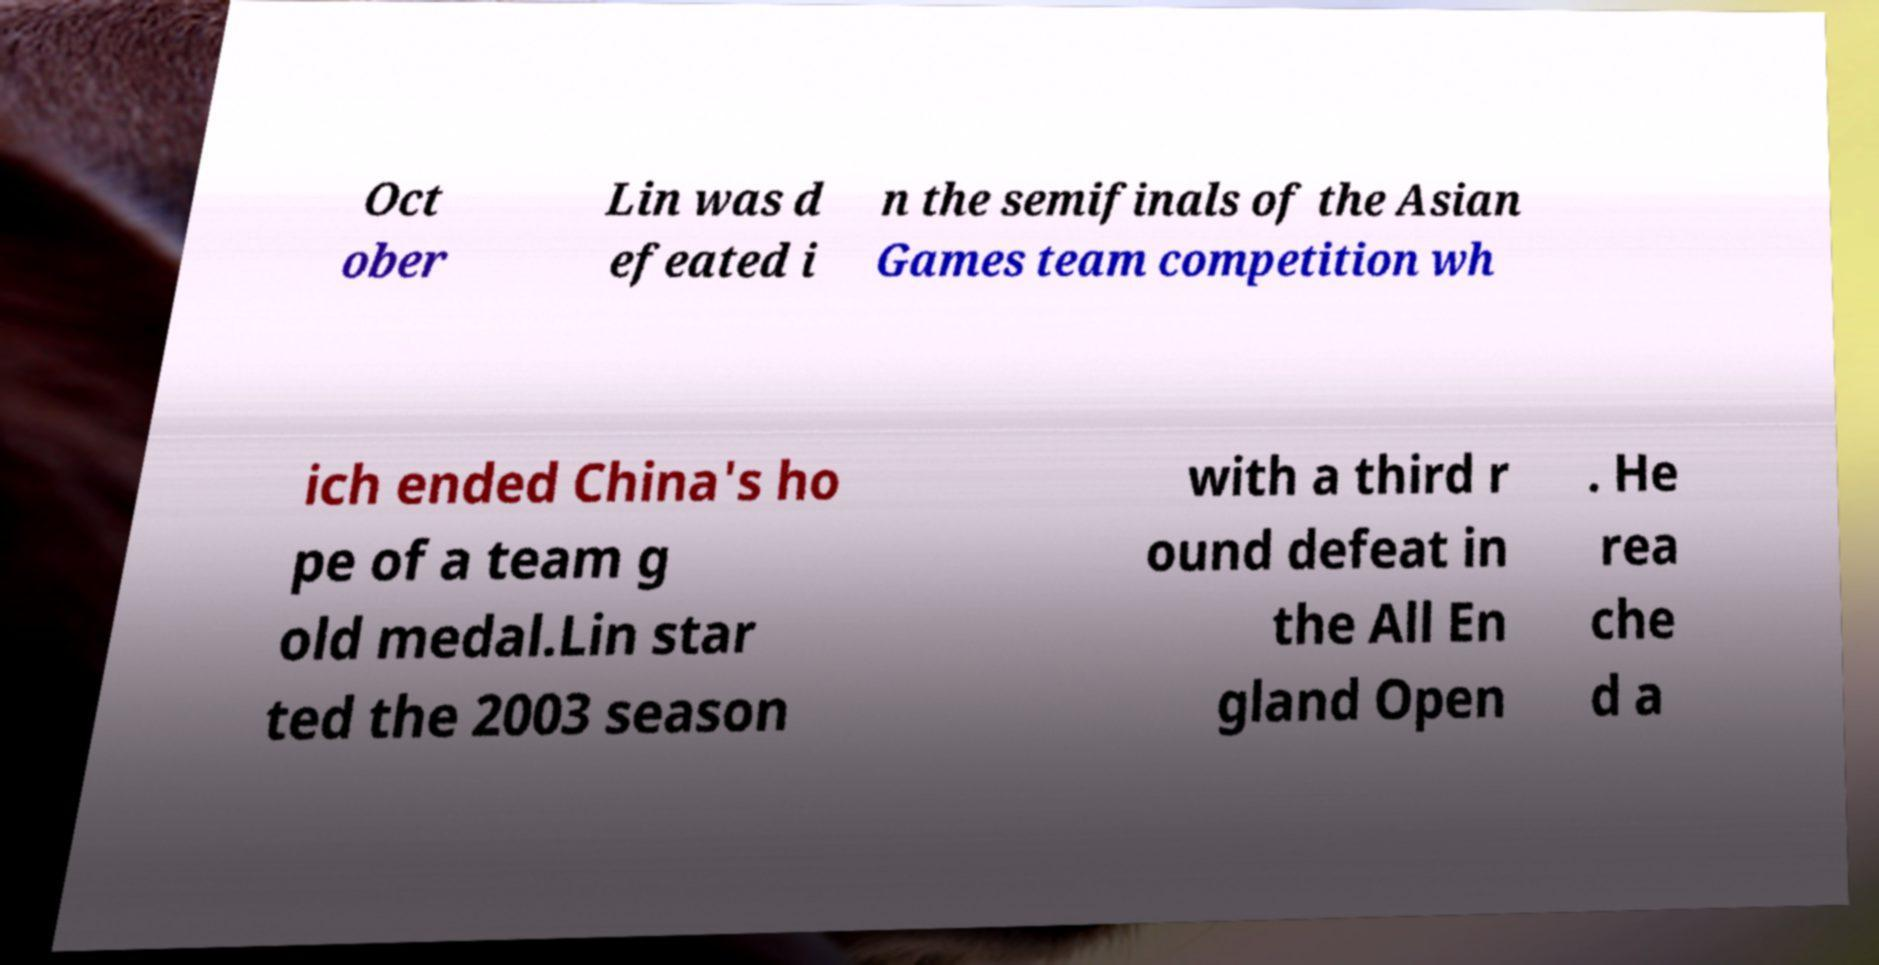Could you extract and type out the text from this image? Oct ober Lin was d efeated i n the semifinals of the Asian Games team competition wh ich ended China's ho pe of a team g old medal.Lin star ted the 2003 season with a third r ound defeat in the All En gland Open . He rea che d a 